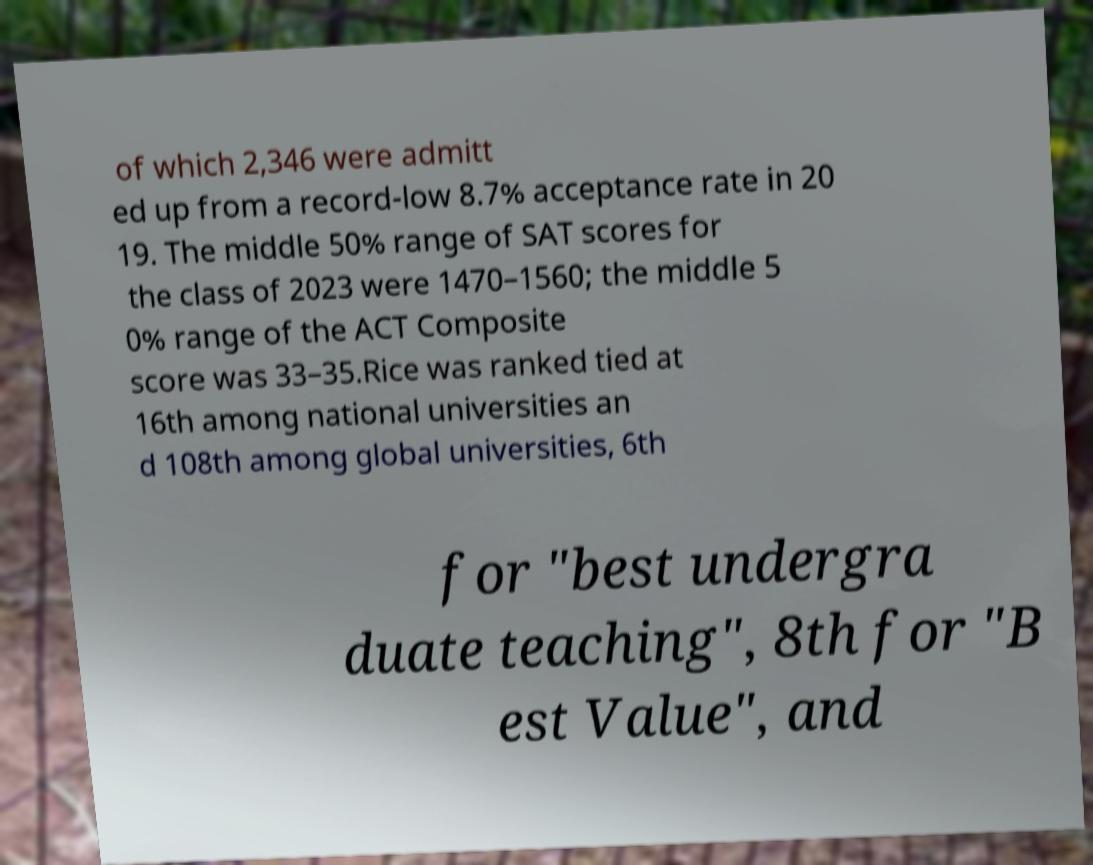I need the written content from this picture converted into text. Can you do that? of which 2,346 were admitt ed up from a record-low 8.7% acceptance rate in 20 19. The middle 50% range of SAT scores for the class of 2023 were 1470–1560; the middle 5 0% range of the ACT Composite score was 33–35.Rice was ranked tied at 16th among national universities an d 108th among global universities, 6th for "best undergra duate teaching", 8th for "B est Value", and 